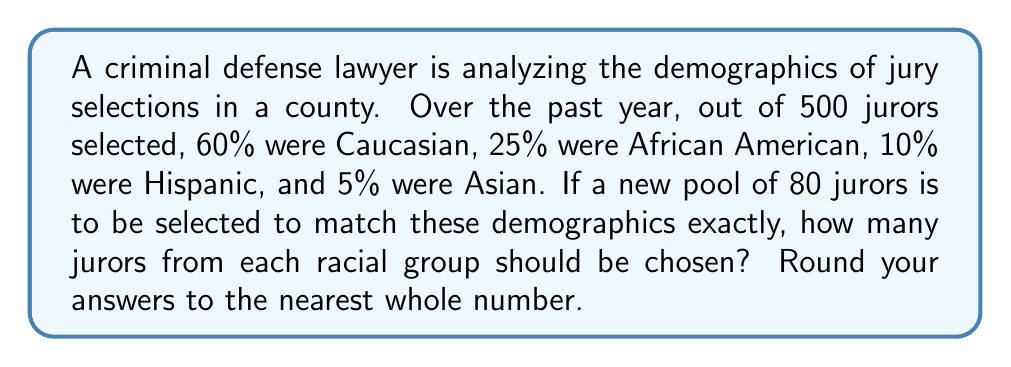Help me with this question. To solve this problem, we need to calculate the number of jurors from each racial group based on the given percentages and the new pool size. Let's break it down step-by-step:

1. Calculate the number of Caucasian jurors:
   $$ \text{Caucasian} = 60\% \times 80 = 0.60 \times 80 = 48 $$

2. Calculate the number of African American jurors:
   $$ \text{African American} = 25\% \times 80 = 0.25 \times 80 = 20 $$

3. Calculate the number of Hispanic jurors:
   $$ \text{Hispanic} = 10\% \times 80 = 0.10 \times 80 = 8 $$

4. Calculate the number of Asian jurors:
   $$ \text{Asian} = 5\% \times 80 = 0.05 \times 80 = 4 $$

5. Round each result to the nearest whole number:
   - Caucasian: 48 (no rounding needed)
   - African American: 20 (no rounding needed)
   - Hispanic: 8 (no rounding needed)
   - Asian: 4 (no rounding needed)

6. Verify that the sum of all groups equals 80:
   $$ 48 + 20 + 8 + 4 = 80 $$

This distribution maintains the exact percentages given in the original data while ensuring a whole number of jurors for each group.
Answer: Caucasian: 48, African American: 20, Hispanic: 8, Asian: 4 